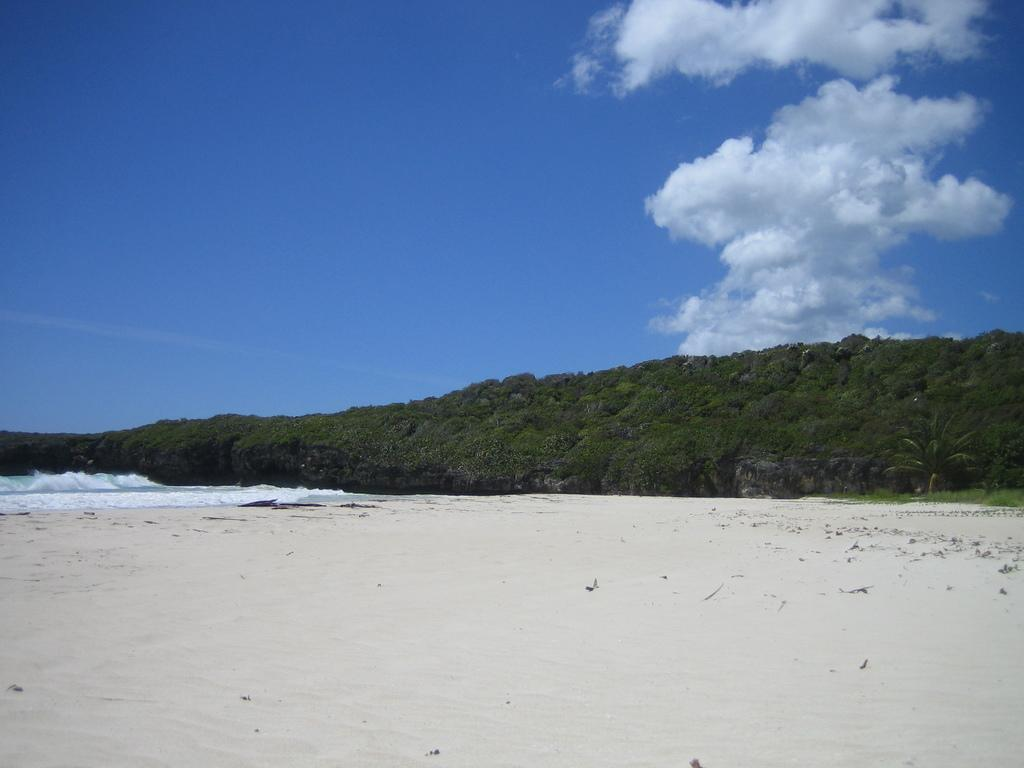Where was the image taken? The image was taken at a beach. What type of vegetation can be seen in the image? There are many trees in the image. What is visible in the sky in the image? The sky is visible with clouds in the image. What type of terrain is visible at the bottom of the image? There is sand visible at the bottom of the image. What is the condition of the blood on the hill in the image? There is no blood or hill present in the image; it is taken at a beach with trees, clouds, and sand. 